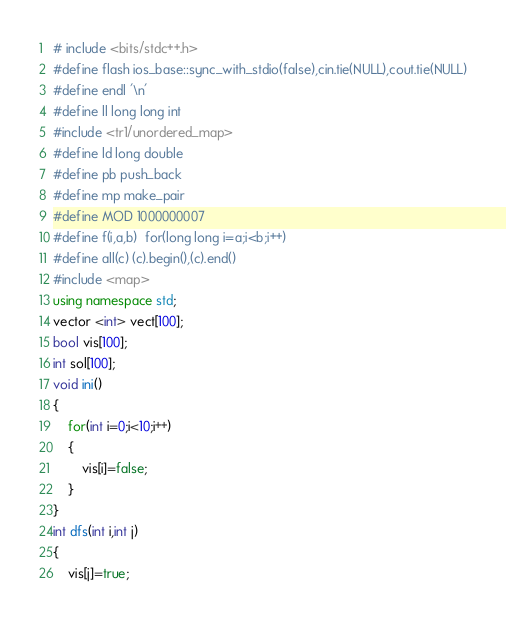<code> <loc_0><loc_0><loc_500><loc_500><_C++_># include <bits/stdc++.h>
#define flash ios_base::sync_with_stdio(false),cin.tie(NULL),cout.tie(NULL)
#define endl '\n'
#define ll long long int
#include <tr1/unordered_map>
#define ld long double
#define pb push_back
#define mp make_pair
#define MOD 1000000007
#define f(i,a,b)  for(long long i=a;i<b;i++)
#define all(c) (c).begin(),(c).end()
#include <map>
using namespace std;
vector <int> vect[100];
bool vis[100];
int sol[100];
void ini()
{
	for(int i=0;i<10;i++)
	{
		vis[i]=false;
	}
}
int dfs(int i,int j)
{
	vis[j]=true;</code> 